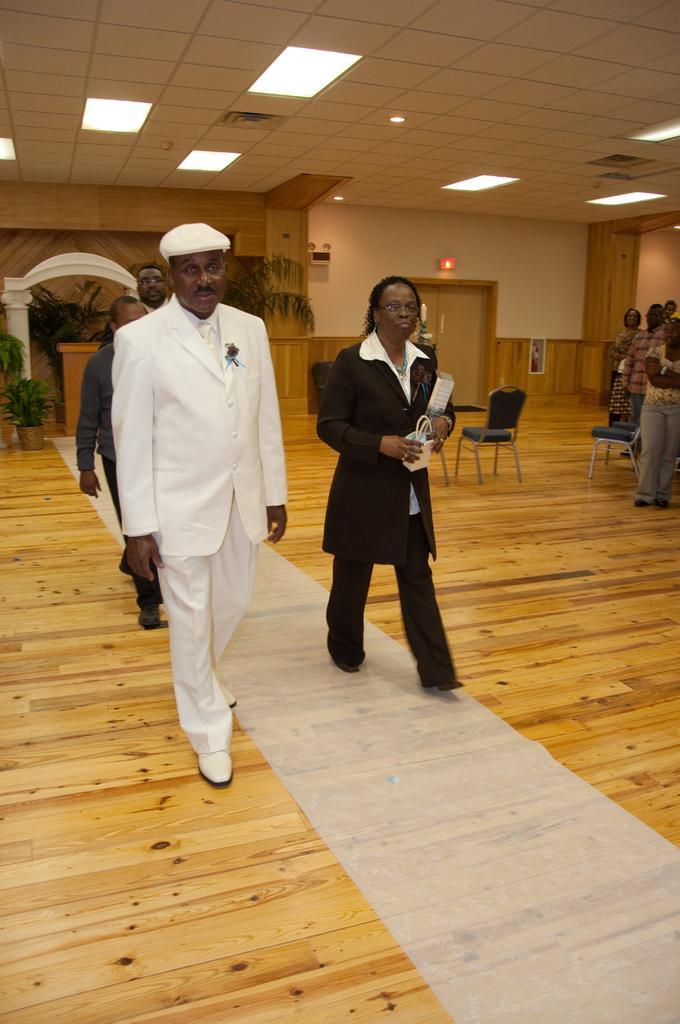Can you describe this image briefly? In this image we can see persons on the wooden floor. In the background we can see electric lights, doors, sign boards, house plants and chairs. 